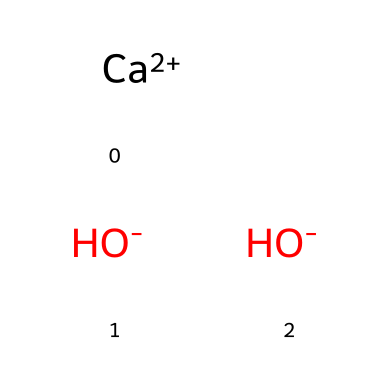What is the molecular formula of this chemical? The molecular formula can be derived from the SMILES representation, which indicates one calcium (Ca) atom, and two hydroxide (OH) ions. Combining these components gives the formula Ca(OH)2.
Answer: Ca(OH)2 How many hydroxide ions are present in the structure? From the SMILES representation, there are two hydroxide ions indicated by the two instances of [OH-].
Answer: 2 What type of compound is calcium hydroxide? Calcium hydroxide is classified as a base because it contains hydroxide ions, which are characteristic of basic compounds that can accept protons.
Answer: base What is the charge of the calcium ion in the structure? In the SMILES representation, calcium is shown as [Ca+2], indicating that it has a +2 positive charge.
Answer: +2 Does this chemical contain any carbon atoms? The SMILES provided does not include any representation of carbon, indicating that there are zero carbon atoms in the structure.
Answer: 0 How many total atoms are in the molecular structure? The structure consists of one calcium atom and two oxygen atoms from hydroxide, plus two hydrogen atoms from the hydroxide groups. Adding these together gives a total of five atoms.
Answer: 5 What is the significance of the hydroxide ions in this compound? Hydroxide ions are responsible for the basic properties of calcium hydroxide, enabling it to neutralize acids and contribute to the pH of materials like plaster and mortar in historic applications.
Answer: basic properties 